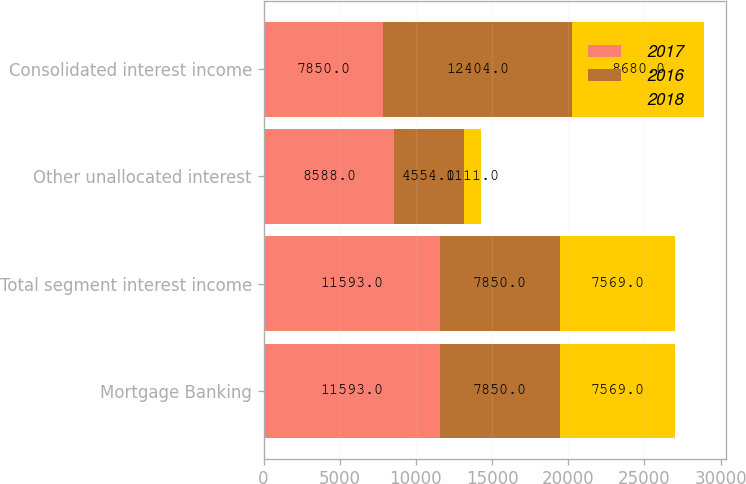Convert chart to OTSL. <chart><loc_0><loc_0><loc_500><loc_500><stacked_bar_chart><ecel><fcel>Mortgage Banking<fcel>Total segment interest income<fcel>Other unallocated interest<fcel>Consolidated interest income<nl><fcel>2017<fcel>11593<fcel>11593<fcel>8588<fcel>7850<nl><fcel>2016<fcel>7850<fcel>7850<fcel>4554<fcel>12404<nl><fcel>2018<fcel>7569<fcel>7569<fcel>1111<fcel>8680<nl></chart> 